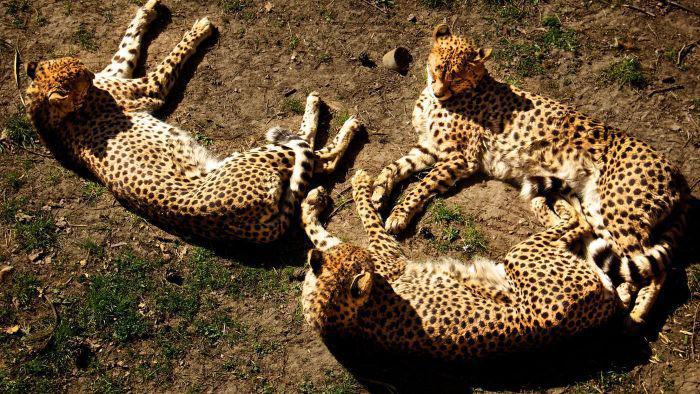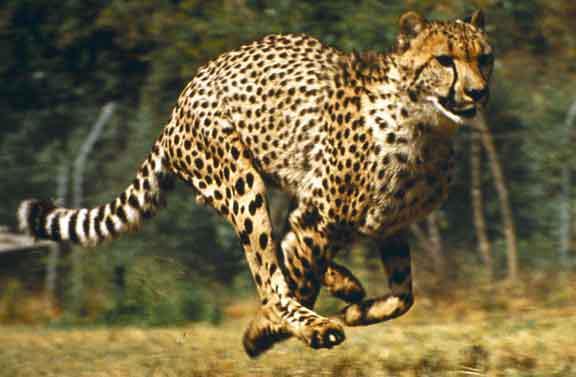The first image is the image on the left, the second image is the image on the right. Analyze the images presented: Is the assertion "The left image contains more cheetahs than the right image." valid? Answer yes or no. Yes. The first image is the image on the left, the second image is the image on the right. For the images displayed, is the sentence "In the leftmost image there are exactly five cheetahs sitting down." factually correct? Answer yes or no. No. 